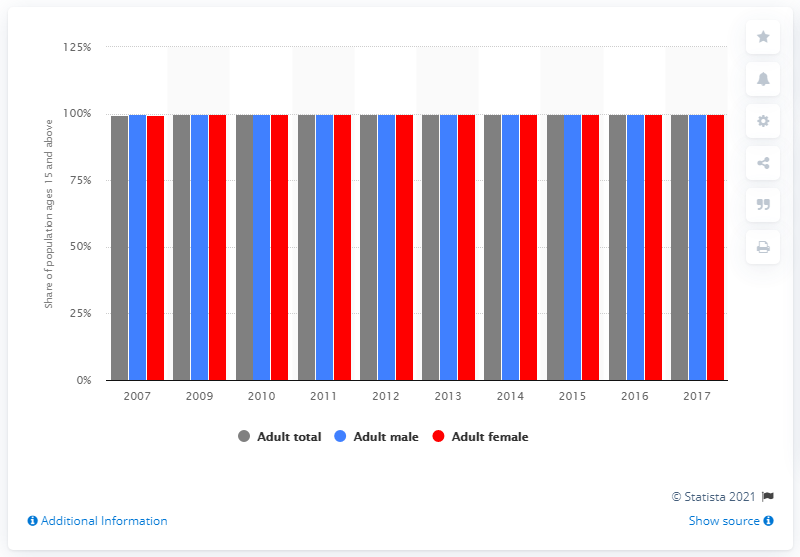Mention a couple of crucial points in this snapshot. In 2017, Azerbaijan had a total literacy rate of 99.79%. 